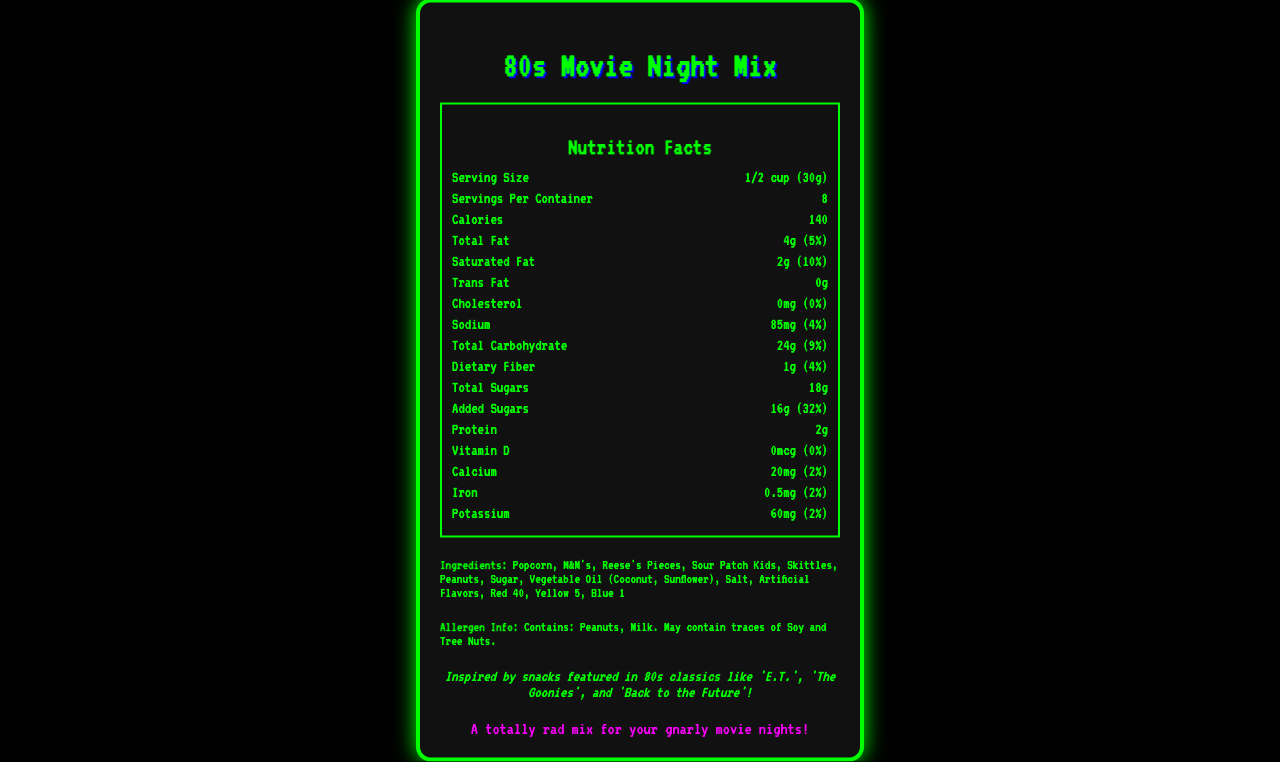what is the serving size of the 80s Movie Night Mix? According to the document, the serving size is listed as 1/2 cup (30g).
Answer: 1/2 cup (30g) how many servings per container are there? The document states that there are 8 servings per container.
Answer: 8 how many calories are in one serving of the 80s Movie Night Mix? The document lists the calorie content as 140 per serving.
Answer: 140 what is the amount of total sugars in one serving? The nutrition label shows that the total sugars amount to 18g per serving.
Answer: 18g what allergens are present in the 80s Movie Night Mix? The allergen information mentions that this product contains Peanuts and Milk.
Answer: Peanuts, Milk what is the percentage daily value of saturated fat in one serving? The document indicates that the percentage daily value of saturated fat is 10%.
Answer: 10% how many grams of protein are in one serving? The document specifies that each serving contains 2g of protein.
Answer: 2g what retro movies inspired the 80s Movie Night Mix? A. Star Wars, E.T., The Goonies B. E.T., The Goonies, Back to the Future C. The Breakfast Club, Ghostbusters, Ferris Bueller's Day Off D. E.T., The Goonies, Ghostbusters The document mentions that it is inspired by snacks featured in 'E.T.', 'The Goonies', and 'Back to the Future'.
Answer: B how much sodium is in one serving of the 80s Movie Night Mix? A. 100mg B. 85mg C. 65mg D. 50mg The label states that there are 85mg of sodium per serving.
Answer: B does the 80s Movie Night Mix contain trans fat? The trans fat amount is listed as 0g in the nutrition facts.
Answer: No can we determine the specific amount of each type of candy in the mix from the label? The document does not provide the specific amounts of each ingredient, only a general list.
Answer: No summarize the main idea of the 80s Movie Night Mix nutrition facts label. The main idea of the document is to present the nutritional content and ingredients of a retro-themed snack mix, highlight its inspiration from 80s movies, and detail the packaging and allergen information.
Answer: The label provides nutritional and allergen information for the "80s Movie Night Mix" snack, including details such as serving size, calories, fat content, sugars, and ingredients. The mix is inspired by popular 80s movies and comes in themed packaging. 